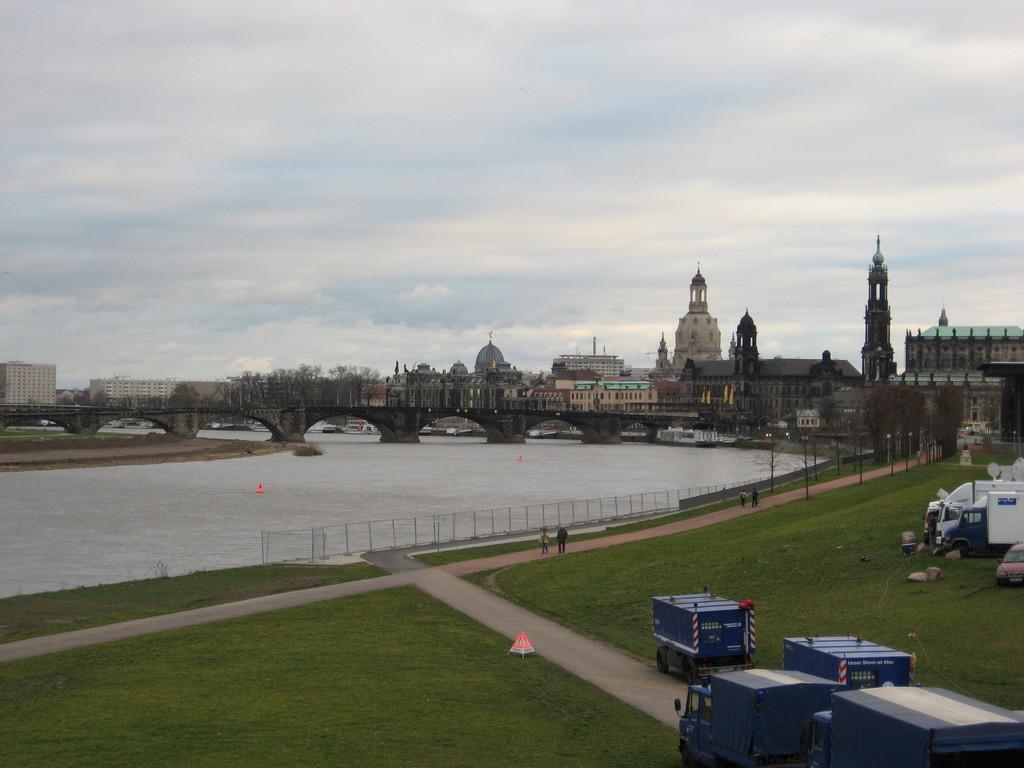Describe this image in one or two sentences. In this Image in the center there is water. In the front there's grass on the ground and there are vehicles. In the background there are buildings and the sky is cloudy. 